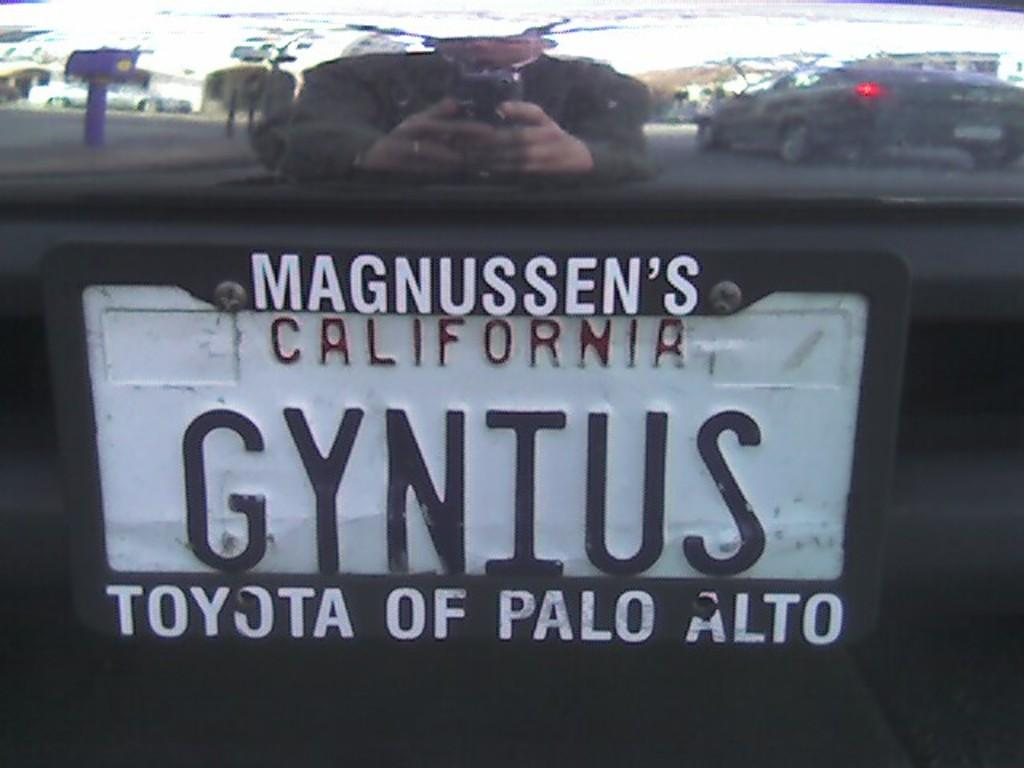<image>
Describe the image concisely. A car license plate from California that reads GYNIUS. 